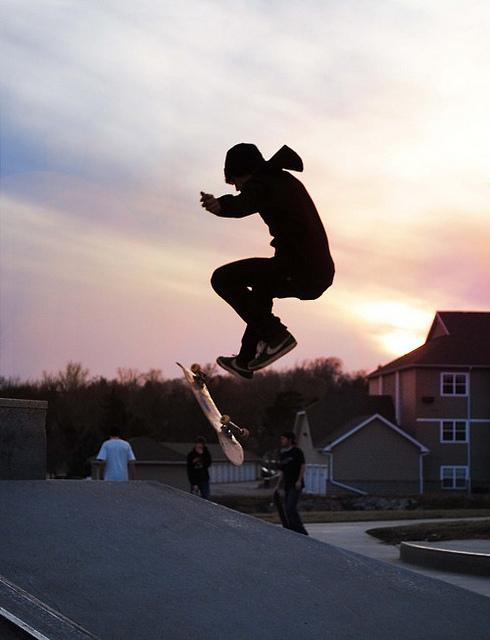What is the guy riding?
Quick response, please. Skateboard. Was this taken at sunset?
Short answer required. Yes. How many people in the picture?
Answer briefly. 4. 